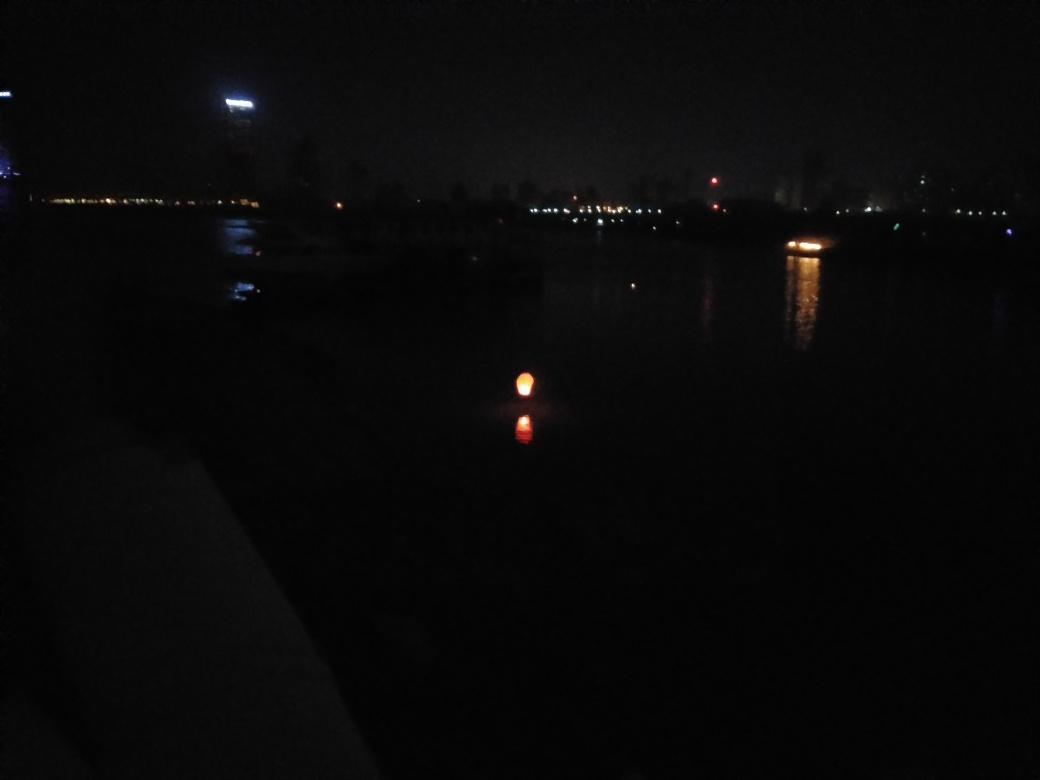Is there any sign of activity in the image? The overall darkness and lack of clear human figures or moving vehicles suggest minimal activity. The main hint of presence is the light source in the water, which might be associated with a stationary or slow-moving object, indicating a low level of activity. 